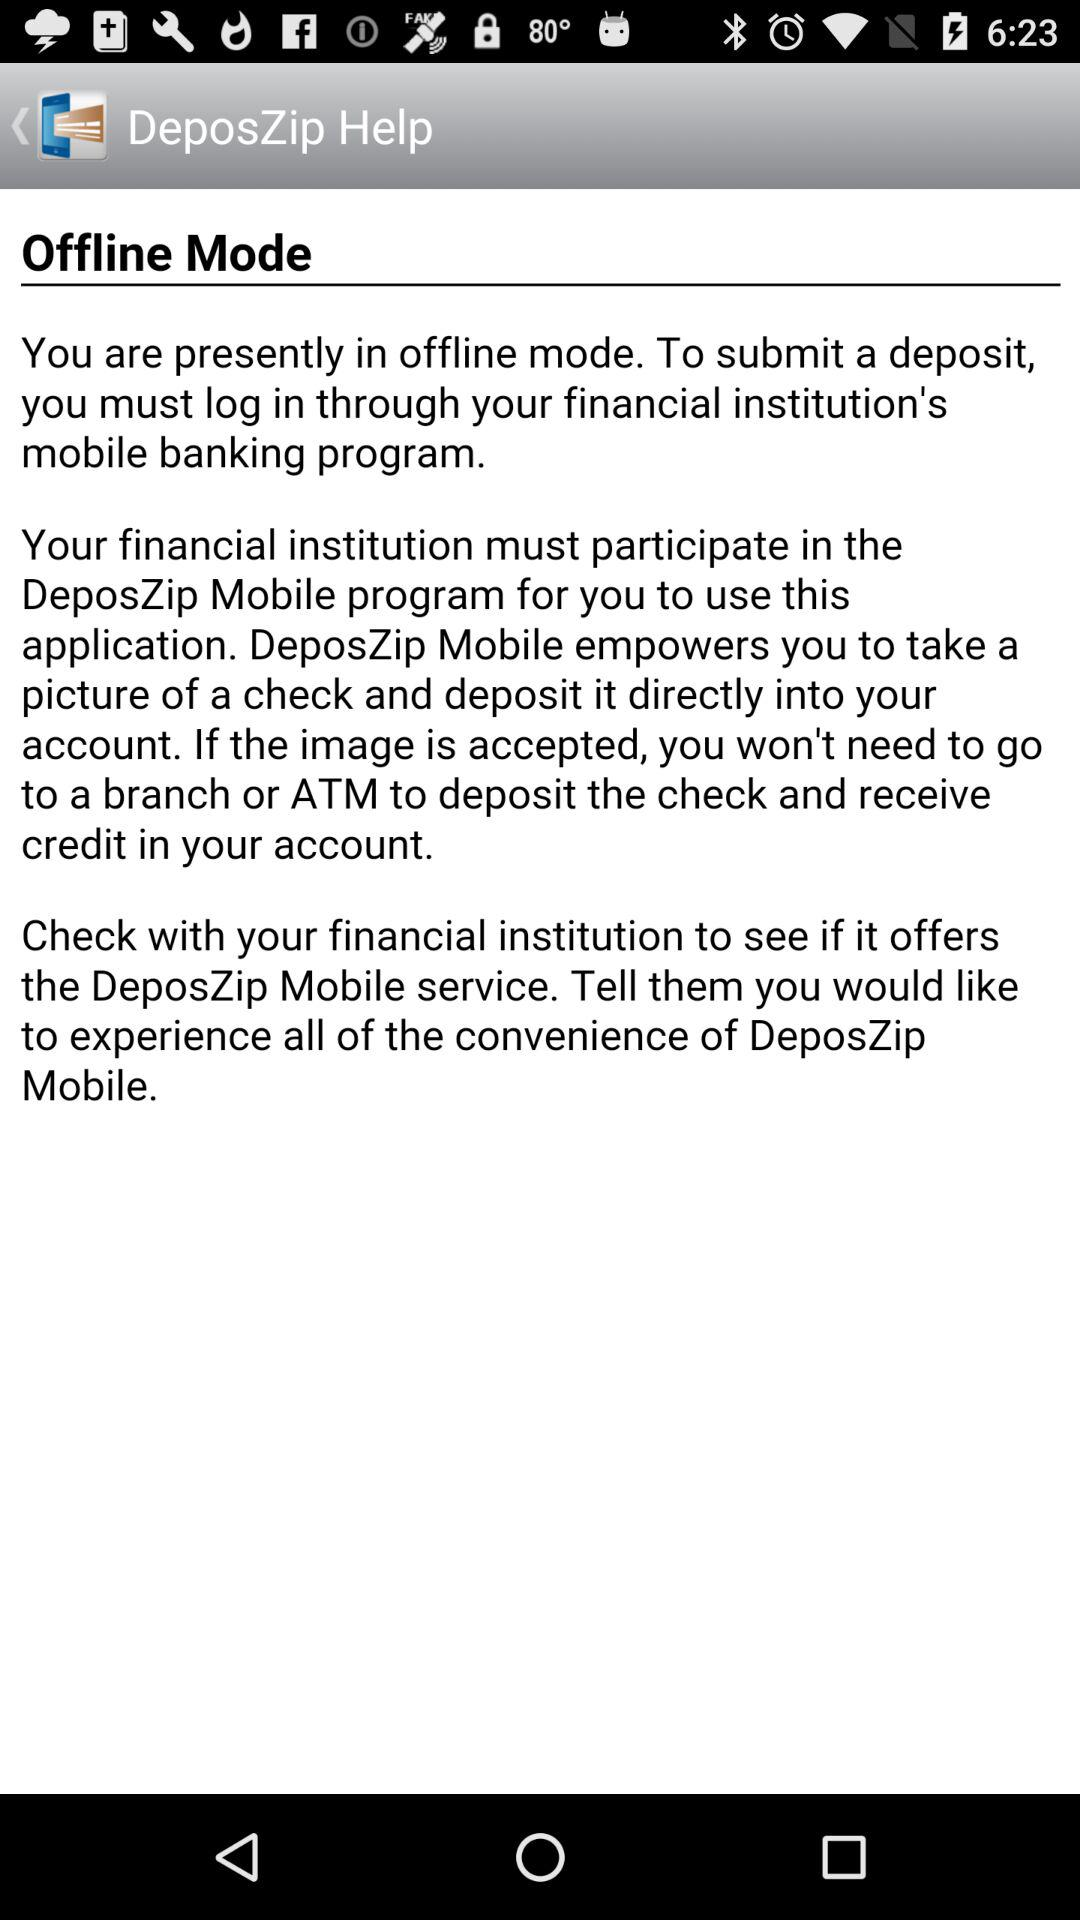What is the name of the application? The name of the application is "DeposZip Help". 